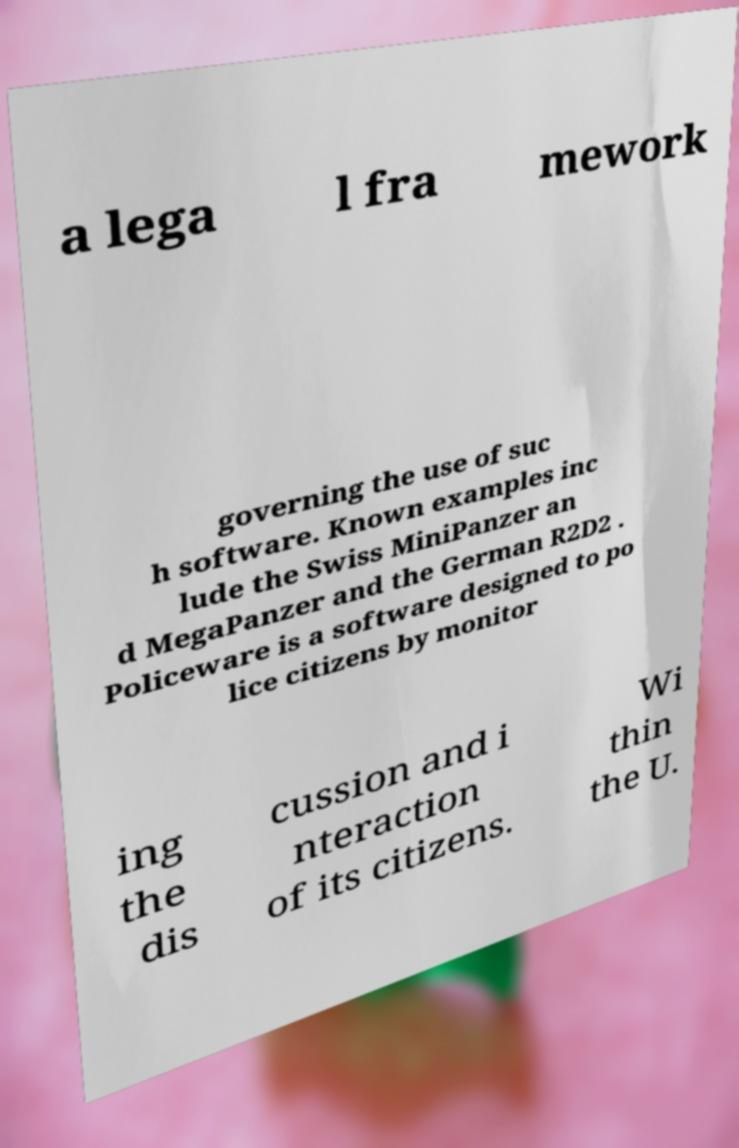Can you accurately transcribe the text from the provided image for me? a lega l fra mework governing the use of suc h software. Known examples inc lude the Swiss MiniPanzer an d MegaPanzer and the German R2D2 . Policeware is a software designed to po lice citizens by monitor ing the dis cussion and i nteraction of its citizens. Wi thin the U. 